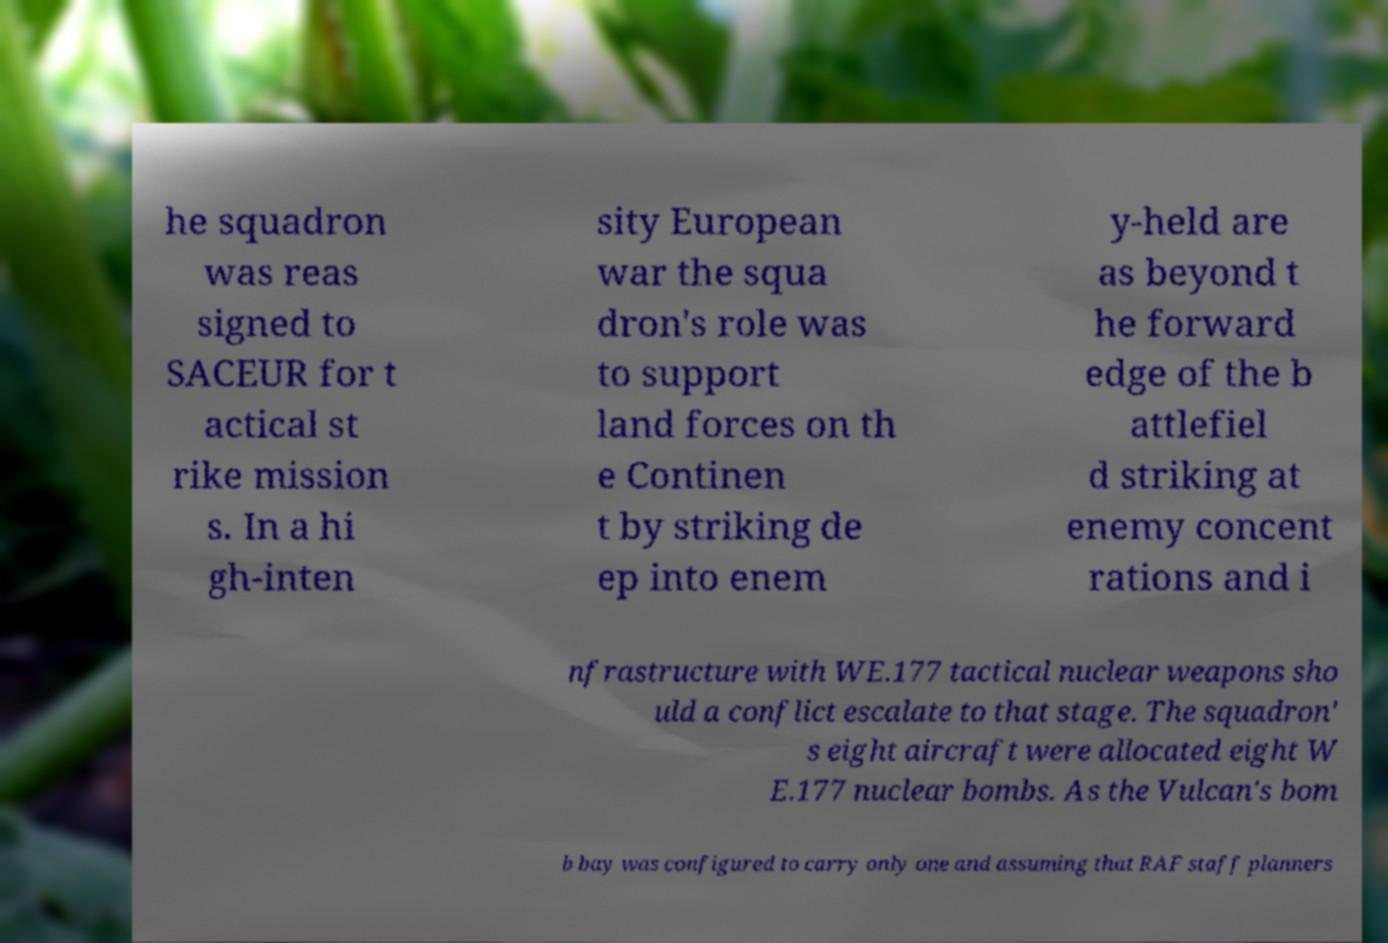Please identify and transcribe the text found in this image. he squadron was reas signed to SACEUR for t actical st rike mission s. In a hi gh-inten sity European war the squa dron's role was to support land forces on th e Continen t by striking de ep into enem y-held are as beyond t he forward edge of the b attlefiel d striking at enemy concent rations and i nfrastructure with WE.177 tactical nuclear weapons sho uld a conflict escalate to that stage. The squadron' s eight aircraft were allocated eight W E.177 nuclear bombs. As the Vulcan's bom b bay was configured to carry only one and assuming that RAF staff planners 